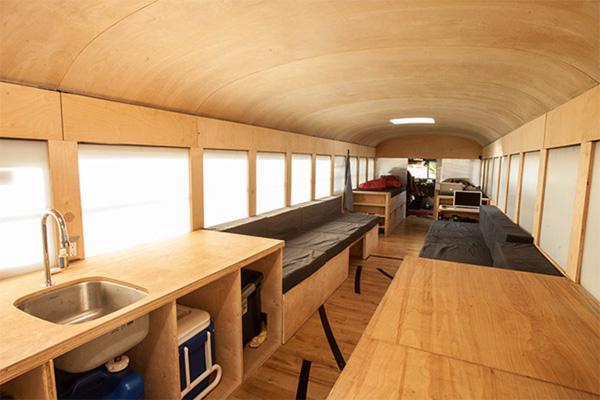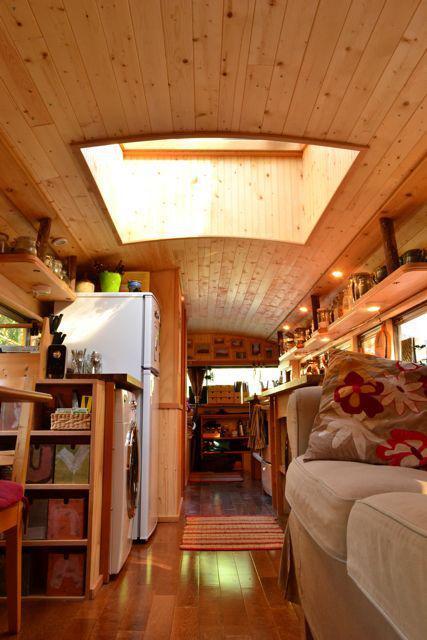The first image is the image on the left, the second image is the image on the right. Examine the images to the left and right. Is the description "There is a small monitor in one of the images, but not the other" accurate? Answer yes or no. Yes. The first image is the image on the left, the second image is the image on the right. Evaluate the accuracy of this statement regarding the images: "The left image shows an interior with a convex curved ceiling that has a squarish skylight in it, and square windows running its length on both sides.". Is it true? Answer yes or no. Yes. 